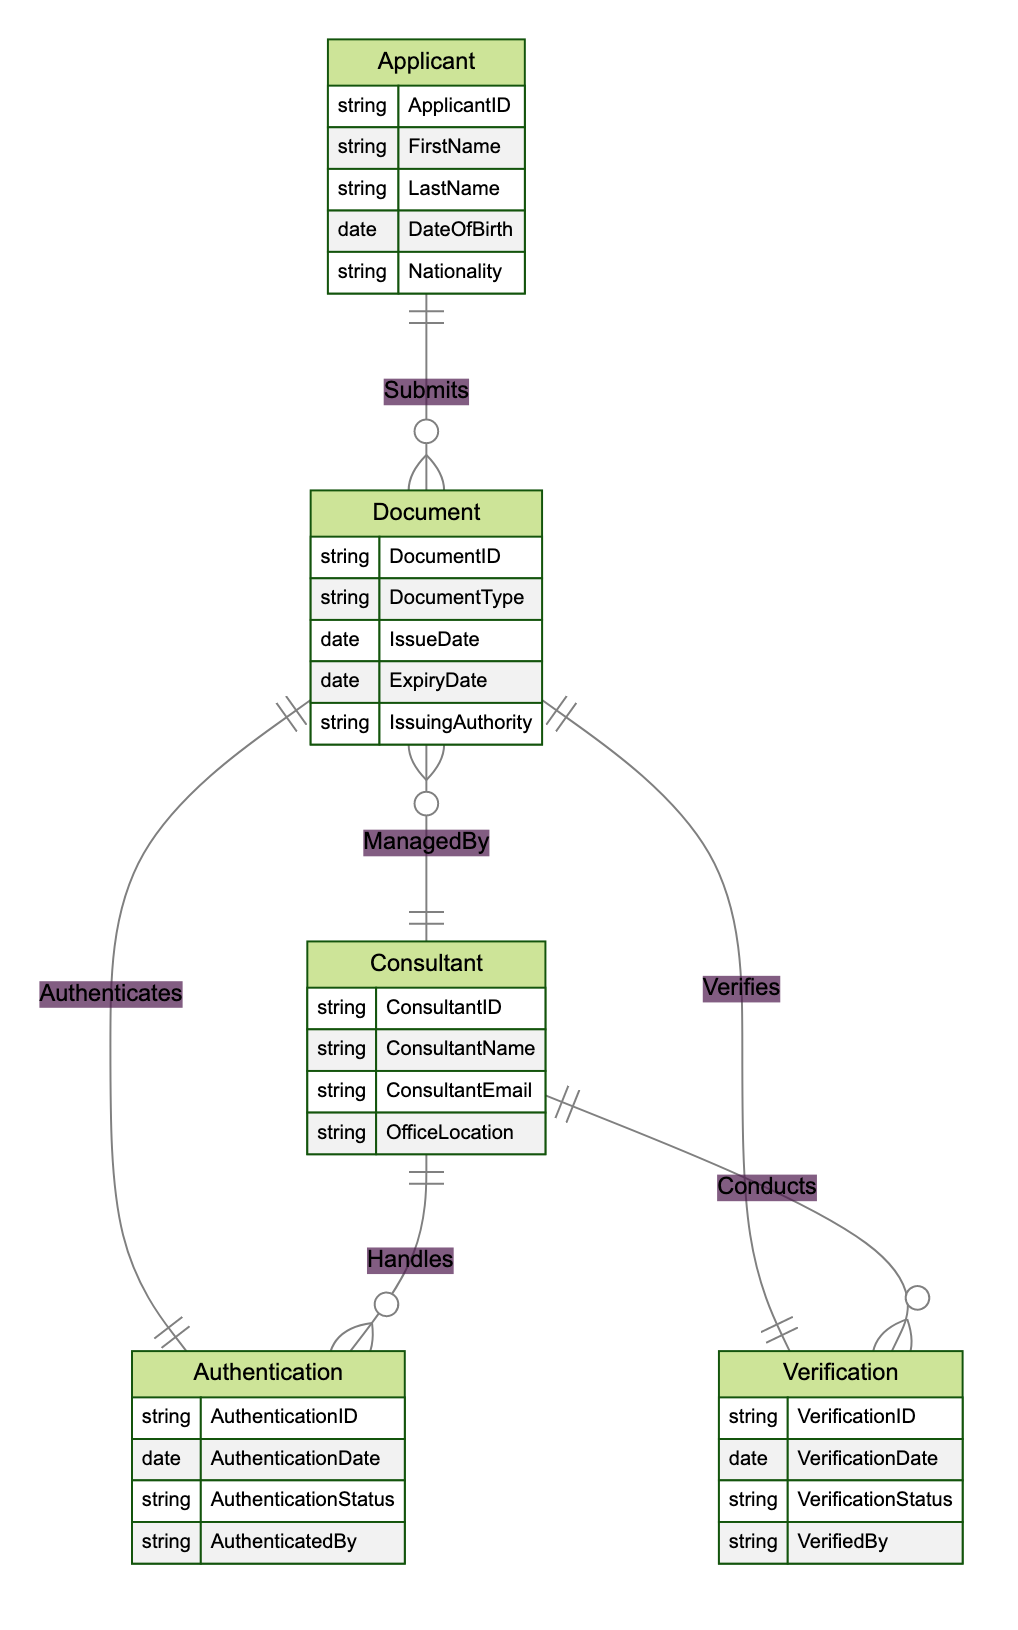What is the document type associated with the Document entity? The Document entity's attributes include a field for DocumentType, which is a characteristic of that entity. To answer this question, one would check the attributes listed within the Document entity, where DocumentType is explicitly mentioned.
Answer: DocumentType How many entities are there in the diagram? Counting the number of entities listed in the provided data, we identify five entities: Applicant, Document, Authentication, Verification, and Consultant. Therefore, the total number of entities is five.
Answer: 5 What relationship connects Consultant and Authentication? The diagram specifies the relationship between Consultant and Authentication as "Handles," which indicates how consultants manage authentication processes related to documents. This relationship is a one-to-many type, meaning one consultant can handle multiple authentications.
Answer: Handles How many documents can an applicant submit? The relationship between Applicant and Document is characterized as "Submits," identified in the diagram as a one-to-many relationship. This suggests that one applicant can submit multiple documents, but each document belongs to one applicant. Thus, the maximum count of documents an applicant can submit can be any number greater than zero.
Answer: One or more Who conducts verifications related to documents? The relationship defined in the diagram between Consultant and Verification is labeled as "Conducts." This indicates that the consultant role is responsible for conducting verifications of the documents. Therefore, consultants conduct verifications.
Answer: Consultant How many authentication records can a single document have? In the diagram, the relationship between Document and Authentication is indicated as "Authenticates," which is a one-to-one type. This means for each document, there can be only one associated authentication record. Therefore, a single document can have only one authentication record.
Answer: One What is the type of relationship between Document and Consultant? The relationship between Document and Consultant is represented as "ManagedBy," denoting that one document is managed by a single consultant, resulting in a many-to-one relationship overall. Consulting practices imply multiple documents can be managed by a single consultant, but each document can only have one consultant managing it.
Answer: ManagedBy How many verifications can a consultant conduct? The diagram describes the relationship between Consultant and Verification as "Conducts," indicating a one-to-many relationship. This implies that a single consultant can conduct multiple verifications related to documents, leading to various potential outcomes based on the number of verifications handled.
Answer: One or more 